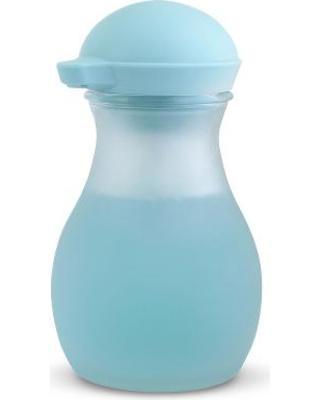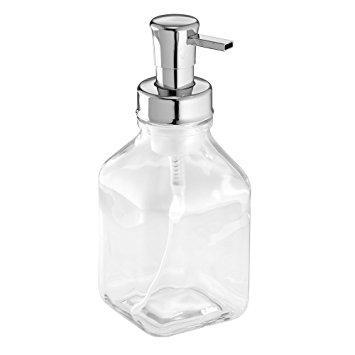The first image is the image on the left, the second image is the image on the right. Analyze the images presented: Is the assertion "The soap dispenser in the left image contains blue soap." valid? Answer yes or no. Yes. The first image is the image on the left, the second image is the image on the right. Assess this claim about the two images: "The right image contains a dispenser with a chrome top.". Correct or not? Answer yes or no. Yes. 